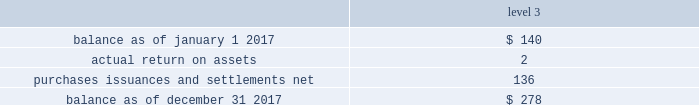The tables present a reconciliation of the beginning and ending balances of the fair value measurements using significant unobservable inputs ( level 3 ) for 2017 and 2016 , respectively: .
Purchases , issuances and settlements , net .
( 4 ) balance as of december 31 , 2016 .
$ 140 the company 2019s postretirement benefit plans have different levels of funded status and the assets are held under various trusts .
The investments and risk mitigation strategies for the plans are tailored specifically for each trust .
In setting new strategic asset mixes , consideration is given to the likelihood that the selected asset allocation will effectively fund the projected plan liabilities and meet the risk tolerance criteria of the company .
The company periodically updates the long-term , strategic asset allocations for these plans through asset liability studies and uses various analytics to determine the optimal asset allocation .
Considerations include plan liability characteristics , liquidity needs , funding requirements , expected rates of return and the distribution of returns .
Strategies to address the goal of ensuring sufficient assets to pay benefits include target allocations to a broad array of asset classes and , within asset classes , strategies are employed to provide adequate returns , diversification and liquidity .
In 2012 , the company implemented a de-risking strategy for the american water pension plan after conducting an asset-liability study to reduce the volatility of the funded status of the plan .
As part of the de-risking strategy , the company revised the asset allocations to increase the matching characteristics of fixed-income assets relative to liabilities .
The fixed income portion of the portfolio was designed to match the bond-like and long-dated nature of the postretirement liabilities .
In 2017 , the company further increased its exposure to liability-driven investing and increased its fixed-income allocation to 50% ( 50 % ) , up from 40% ( 40 % ) , in an effort to further decrease the funded status volatility of the plan and hedge the portfolio from movements in interest rates .
In 2012 , the company also implemented a de-risking strategy for the medical bargaining trust within the plan to minimize volatility .
In 2017 , the company conducted a new asset-liability study that indicated medical trend inflation that outpaced the consumer price index by more than 2% ( 2 % ) for the last 20 years .
Given continuously rising medical costs , the company decided to increase the equity exposure of the portfolio to 30% ( 30 % ) , up from 20% ( 20 % ) , while reducing the fixed-income portion of the portfolio from 80% ( 80 % ) to 70% ( 70 % ) .
The company also conducted an asset-liability study for the post-retirement non-bargaining medical plan .
Its allocation was adjusted to make it more conservative , reducing the equity allocation from 70% ( 70 % ) to 60% ( 60 % ) and increasing the fixed- income allocation from 30% ( 30 % ) to 40% ( 40 % ) .
The post-retirement medical non-bargaining plan 2019s equity allocation was reduced due to the cap on benefits for some non-union participants and resultant reduction in the plan 2019s liabilities .
These changes will take place in 2018 .
The company engages third party investment managers for all invested assets .
Managers are not permitted to invest outside of the asset class ( e.g .
Fixed income , equity , alternatives ) or strategy for which they have been appointed .
Investment management agreements and recurring performance and attribution analysis are used as tools to ensure investment managers invest solely within the investment strategy they have been provided .
Futures and options may be used to adjust portfolio duration to align with a plan 2019s targeted investment policy. .
What was the actual return on assets as a percentage of beginning 2017 balance? 
Computations: (2 / 140)
Answer: 0.01429. 